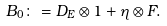Convert formula to latex. <formula><loc_0><loc_0><loc_500><loc_500>B _ { 0 } \colon = D _ { E } \otimes 1 + \eta \otimes F .</formula> 